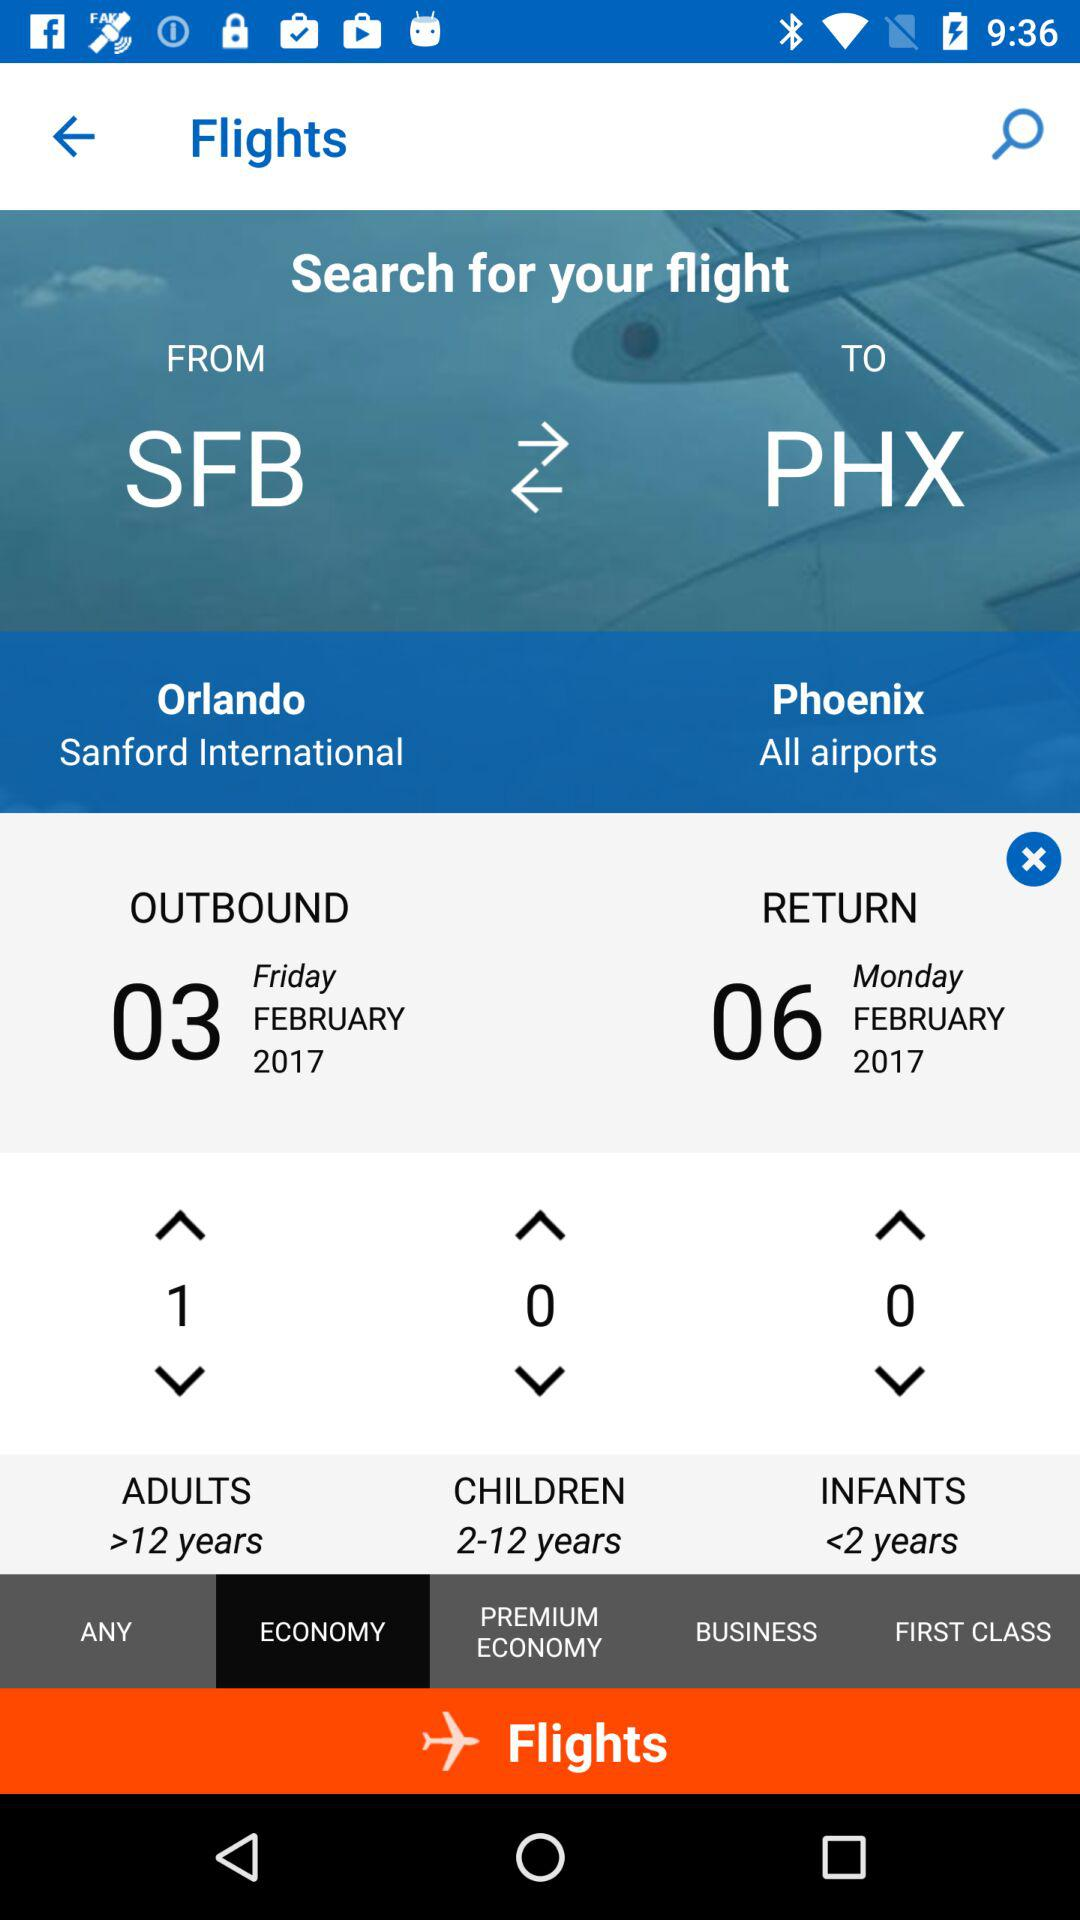How many more days are there between the departure and return dates?
Answer the question using a single word or phrase. 3 